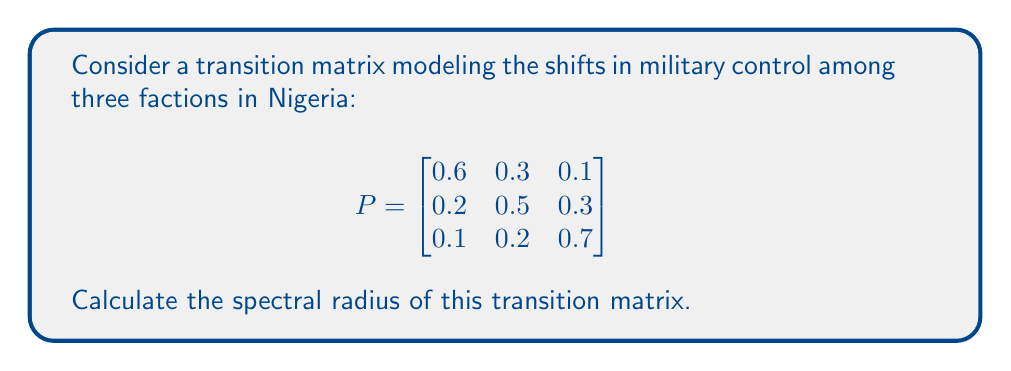Help me with this question. To calculate the spectral radius of the transition matrix P, we need to follow these steps:

1. Find the characteristic polynomial of P:
   $det(P - \lambda I) = 0$

2. Solve for the eigenvalues:
   $$\begin{vmatrix}
   0.6-\lambda & 0.3 & 0.1 \\
   0.2 & 0.5-\lambda & 0.3 \\
   0.1 & 0.2 & 0.7-\lambda
   \end{vmatrix} = 0$$

3. Expanding the determinant:
   $(0.6-\lambda)[(0.5-\lambda)(0.7-\lambda) - 0.06] - 0.3[0.2(0.7-\lambda) - 0.03] + 0.1[0.2(0.5-\lambda) - 0.06] = 0$

4. Simplifying:
   $-\lambda^3 + 1.8\lambda^2 - 0.83\lambda + 0.1 = 0$

5. Solving this cubic equation (using a computer algebra system or numerical methods) gives us the eigenvalues:
   $\lambda_1 \approx 1$
   $\lambda_2 \approx 0.5$
   $\lambda_3 \approx 0.3$

6. The spectral radius is the largest absolute value of the eigenvalues:
   $\rho(P) = \max(|\lambda_1|, |\lambda_2|, |\lambda_3|) = \max(1, 0.5, 0.3) = 1$

Note: The largest eigenvalue being 1 is expected for a stochastic matrix, which models probabilities of transitions between states.
Answer: $\rho(P) = 1$ 